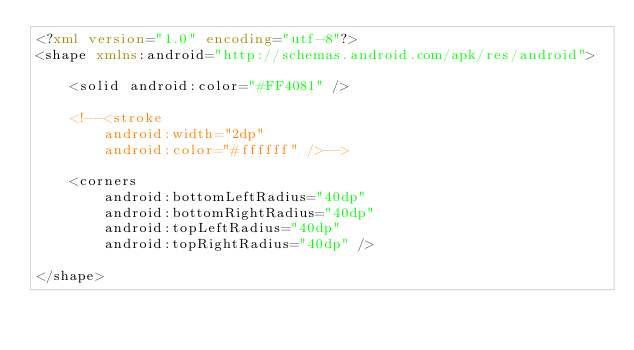<code> <loc_0><loc_0><loc_500><loc_500><_XML_><?xml version="1.0" encoding="utf-8"?>
<shape xmlns:android="http://schemas.android.com/apk/res/android">

    <solid android:color="#FF4081" />

    <!--<stroke
        android:width="2dp"
        android:color="#ffffff" />-->

    <corners
        android:bottomLeftRadius="40dp"
        android:bottomRightRadius="40dp"
        android:topLeftRadius="40dp"
        android:topRightRadius="40dp" />

</shape></code> 